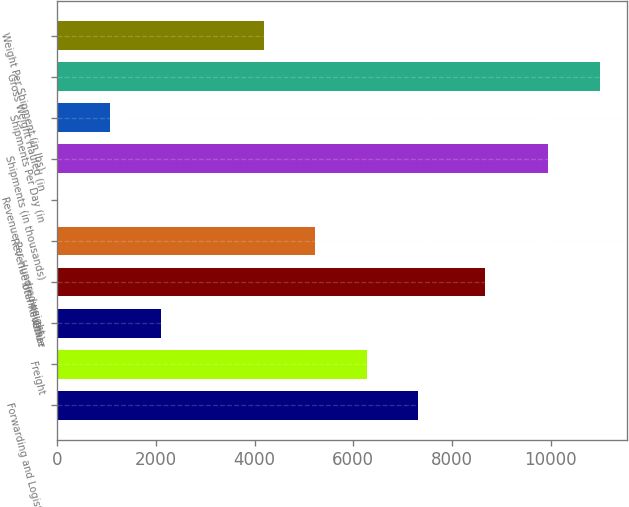Convert chart to OTSL. <chart><loc_0><loc_0><loc_500><loc_500><bar_chart><fcel>Forwarding and Logistics<fcel>Freight<fcel>Other<fcel>Total Revenue<fcel>Revenue (in millions)<fcel>Revenue Per Hundredweight<fcel>Shipments (in thousands)<fcel>Shipments Per Day (in<fcel>Gross Weight Hauled (in<fcel>Weight Per Shipment (in lbs)<nl><fcel>7313.74<fcel>6271.66<fcel>2103.34<fcel>8670<fcel>5229.58<fcel>19.18<fcel>9952<fcel>1061.26<fcel>10994.1<fcel>4187.5<nl></chart> 